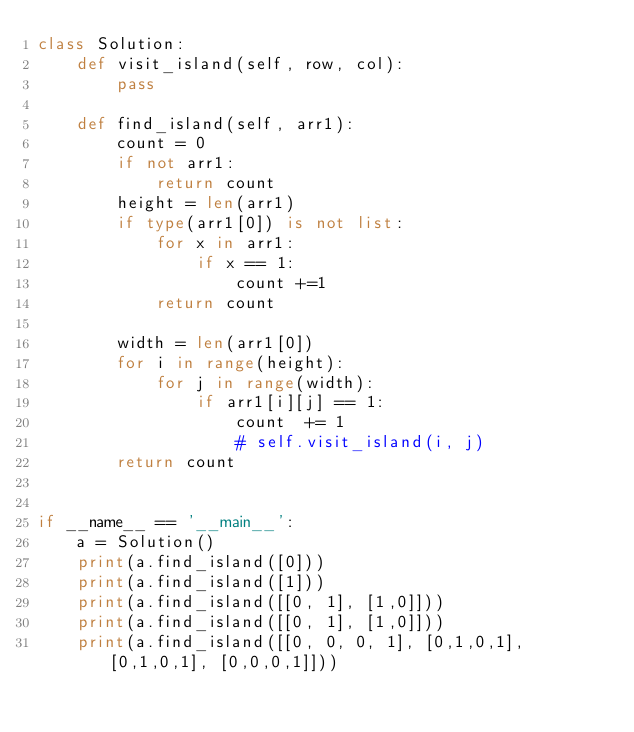<code> <loc_0><loc_0><loc_500><loc_500><_Python_>class Solution:
    def visit_island(self, row, col):
        pass

    def find_island(self, arr1):
        count = 0
        if not arr1:
            return count
        height = len(arr1)
        if type(arr1[0]) is not list:
            for x in arr1:
                if x == 1:
                    count +=1
            return count

        width = len(arr1[0])
        for i in range(height):
            for j in range(width):
                if arr1[i][j] == 1:
                    count  += 1
                    # self.visit_island(i, j)
        return count


if __name__ == '__main__':
    a = Solution()
    print(a.find_island([0]))
    print(a.find_island([1]))
    print(a.find_island([[0, 1], [1,0]]))
    print(a.find_island([[0, 1], [1,0]]))
    print(a.find_island([[0, 0, 0, 1], [0,1,0,1], [0,1,0,1], [0,0,0,1]]))
</code> 